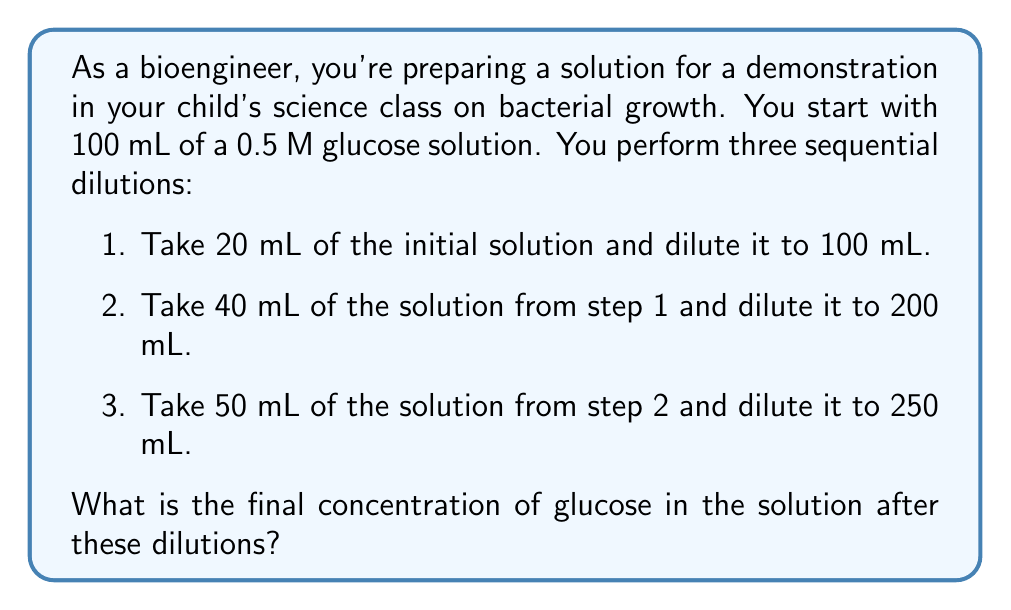Teach me how to tackle this problem. Let's approach this step-by-step using the dilution formula:

$$ C_1V_1 = C_2V_2 $$

Where $C_1$ is the initial concentration, $V_1$ is the initial volume, $C_2$ is the final concentration, and $V_2$ is the final volume.

1. First dilution:
   $$ 0.5 \text{ M} \cdot 20 \text{ mL} = C_2 \cdot 100 \text{ mL} $$
   $$ C_2 = \frac{0.5 \text{ M} \cdot 20 \text{ mL}}{100 \text{ mL}} = 0.1 \text{ M} $$

2. Second dilution:
   $$ 0.1 \text{ M} \cdot 40 \text{ mL} = C_3 \cdot 200 \text{ mL} $$
   $$ C_3 = \frac{0.1 \text{ M} \cdot 40 \text{ mL}}{200 \text{ mL}} = 0.02 \text{ M} $$

3. Third dilution:
   $$ 0.02 \text{ M} \cdot 50 \text{ mL} = C_4 \cdot 250 \text{ mL} $$
   $$ C_4 = \frac{0.02 \text{ M} \cdot 50 \text{ mL}}{250 \text{ mL}} = 0.004 \text{ M} $$

Therefore, the final concentration after all three dilutions is 0.004 M or 4 mM.
Answer: The final concentration of glucose in the solution after the three dilutions is 0.004 M (4 mM). 